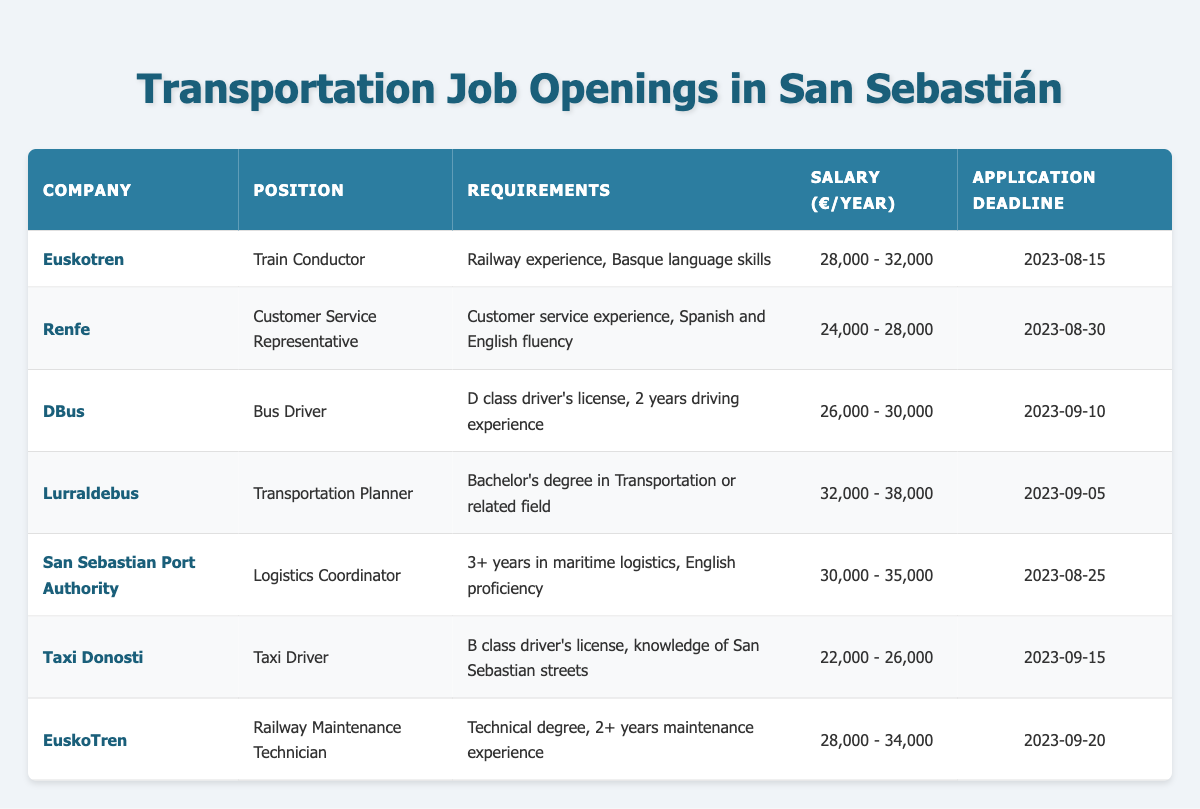What position at Euskotren requires Basque language skills? The table shows the positions offered by various companies including Euskotren. The position listed for Euskotren that requires Basque language skills is "Train Conductor."
Answer: Train Conductor Which job has the highest salary range? Reviewing the salary columns of all job listings, the position with the highest salary range is "Transportation Planner" at Lurraldebus, with a salary range of 32,000 - 38,000 euros per year.
Answer: Transportation Planner Is there a position that does not require any specific language skills? Checking the requirements for each job, the "Taxi Driver" position at Taxi Donosti does not mention any specific language skills as a requirement, only a B class driver's license and knowledge of San Sebastián streets.
Answer: Yes What is the average salary range for the positions listed? To find the average salary range, we can take the midpoints of each salary range: (30,000 + 28,000 + 28,000 + 35,000 + 33,000 + 24,000 + 34,000) / 7 = 29,714. The average salary range is approximately 29,714 euros per year.
Answer: 29,714 Which position has the earliest application deadline? The position with the earliest application deadline can be found by reviewing the last column of the table. The earliest application deadline is 2023-08-15 for the "Train Conductor" position at Euskotren.
Answer: Train Conductor 